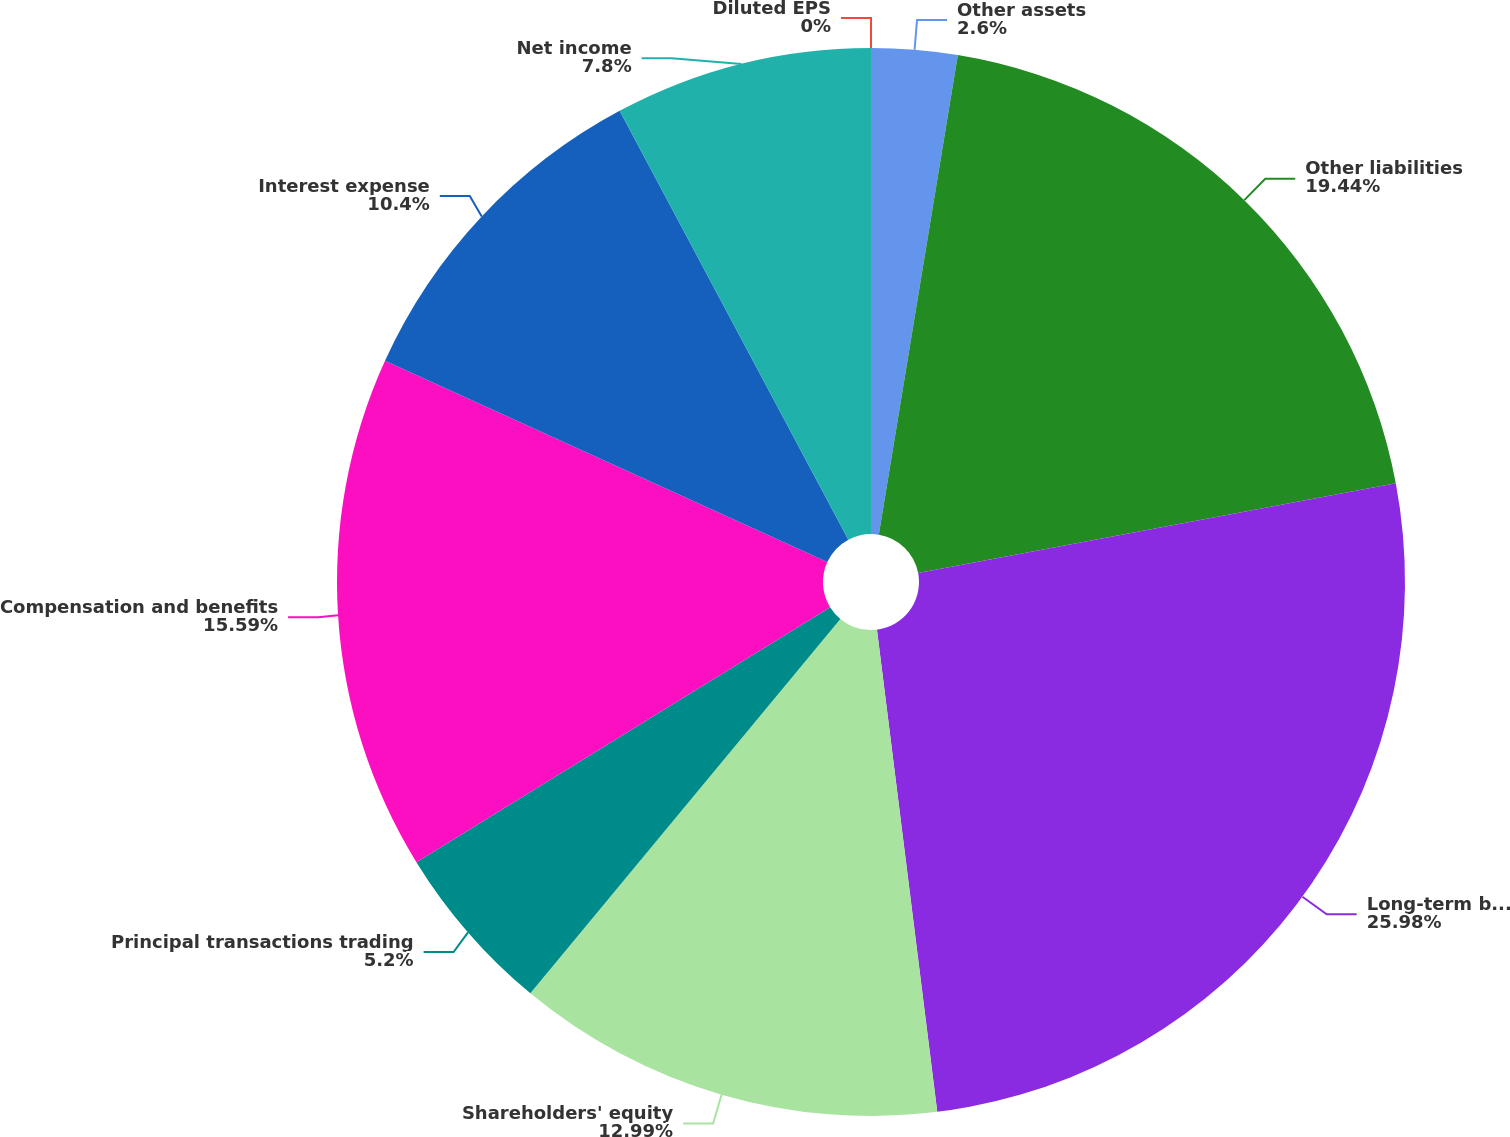Convert chart. <chart><loc_0><loc_0><loc_500><loc_500><pie_chart><fcel>Other assets<fcel>Other liabilities<fcel>Long-term borrowings<fcel>Shareholders' equity<fcel>Principal transactions trading<fcel>Compensation and benefits<fcel>Interest expense<fcel>Net income<fcel>Diluted EPS<nl><fcel>2.6%<fcel>19.44%<fcel>25.98%<fcel>12.99%<fcel>5.2%<fcel>15.59%<fcel>10.4%<fcel>7.8%<fcel>0.0%<nl></chart> 